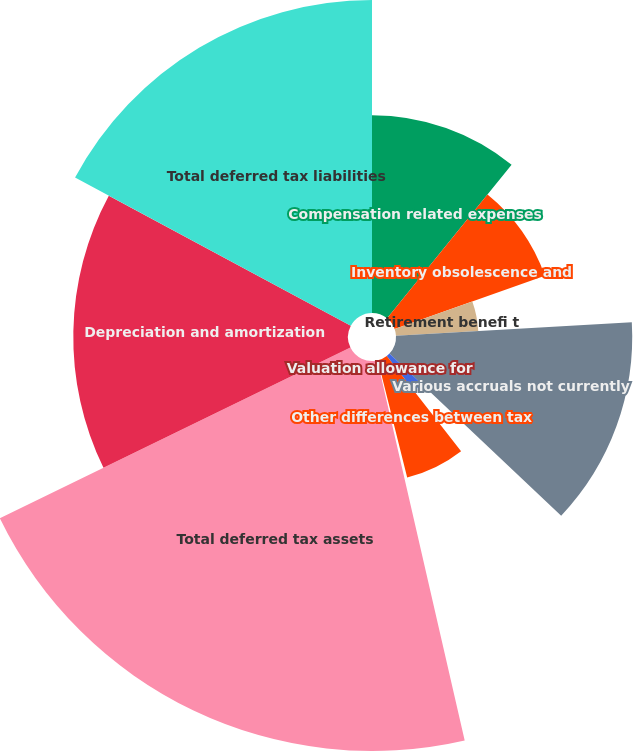Convert chart to OTSL. <chart><loc_0><loc_0><loc_500><loc_500><pie_chart><fcel>Compensation related expenses<fcel>Inventory obsolescence and<fcel>Retirement benefi t<fcel>Various accruals not currently<fcel>Net operating loss and credit<fcel>Other differences between tax<fcel>Valuation allowance for<fcel>Total deferred tax assets<fcel>Depreciation and amortization<fcel>Total deferred tax liabilities<nl><fcel>10.84%<fcel>8.74%<fcel>4.52%<fcel>12.95%<fcel>2.42%<fcel>6.63%<fcel>0.31%<fcel>21.38%<fcel>15.06%<fcel>17.16%<nl></chart> 